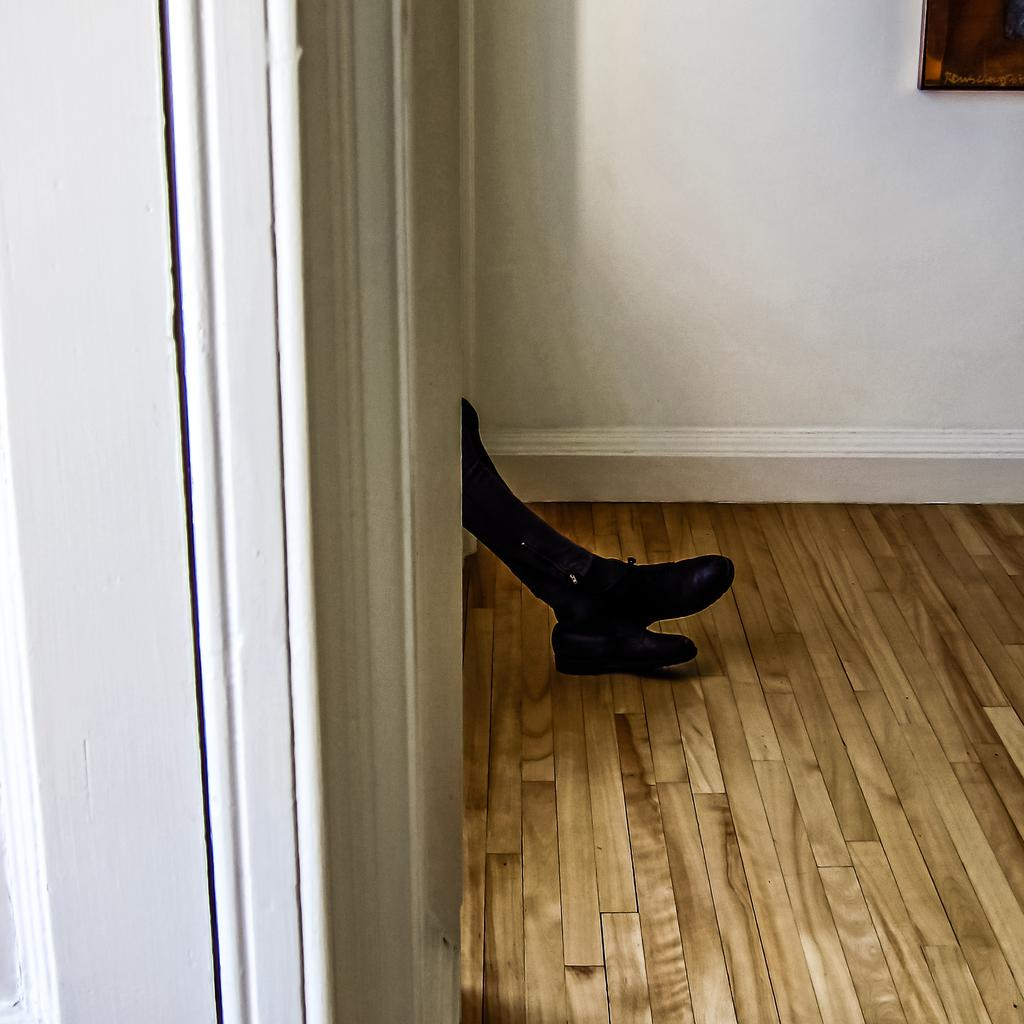What part of a person can be seen in the image? There are legs of a person visible in the image. What type of flooring is present at the bottom of the image? There is a wooden floor at the bottom of the image. What can be seen hanging on the wall in the background of the image? There is a frame hanging on the wall in the background of the image. What type of steel structure can be seen in the middle of the image? There is no steel structure present in the image; it only features a person's legs, a wooden floor, and a frame on the wall. How many clouds are visible in the image? There are no clouds visible in the image, as it does not depict an outdoor scene. 